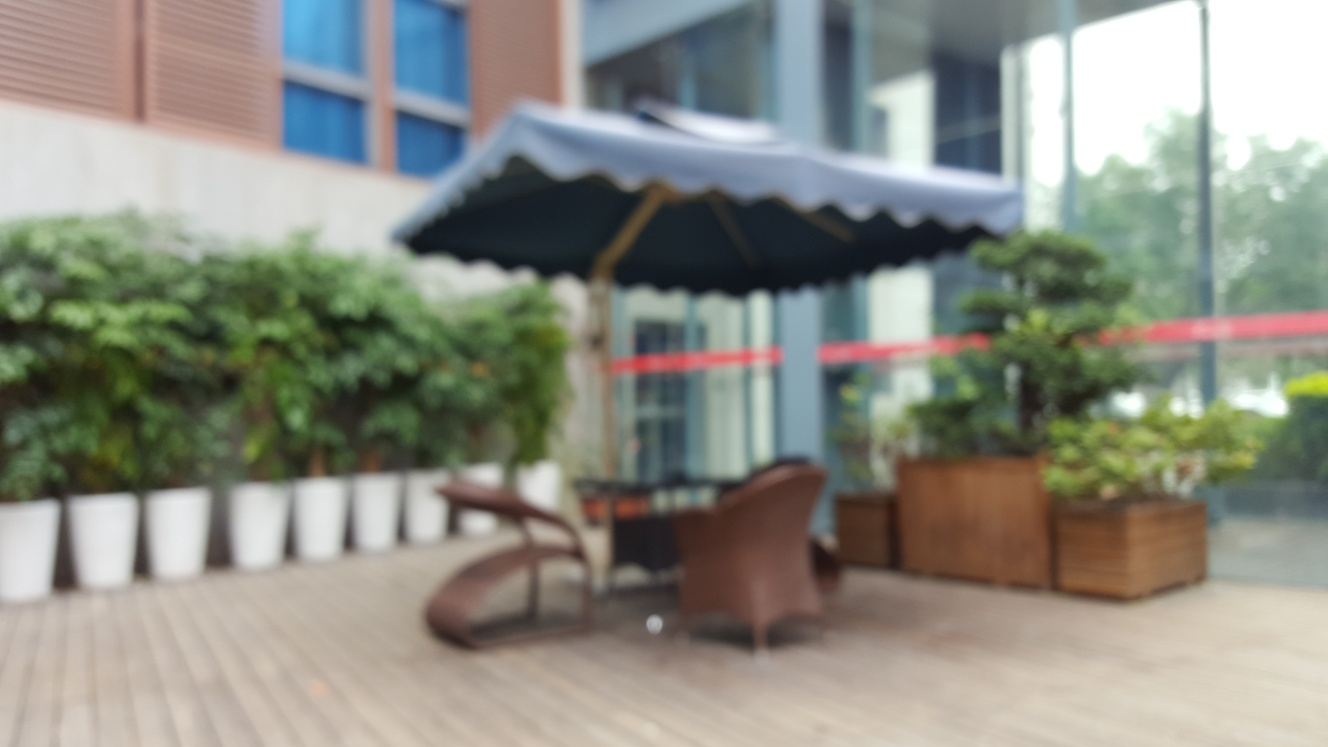What kind of establishment could this outdoor seating area belong to? The outdoor seating arrangement with an umbrella and what appears to be planters indicates it could be part of a café, restaurant, or a public space like a park where people might enjoy a break outdoors. The setting looks designed for relaxation and social interaction. 